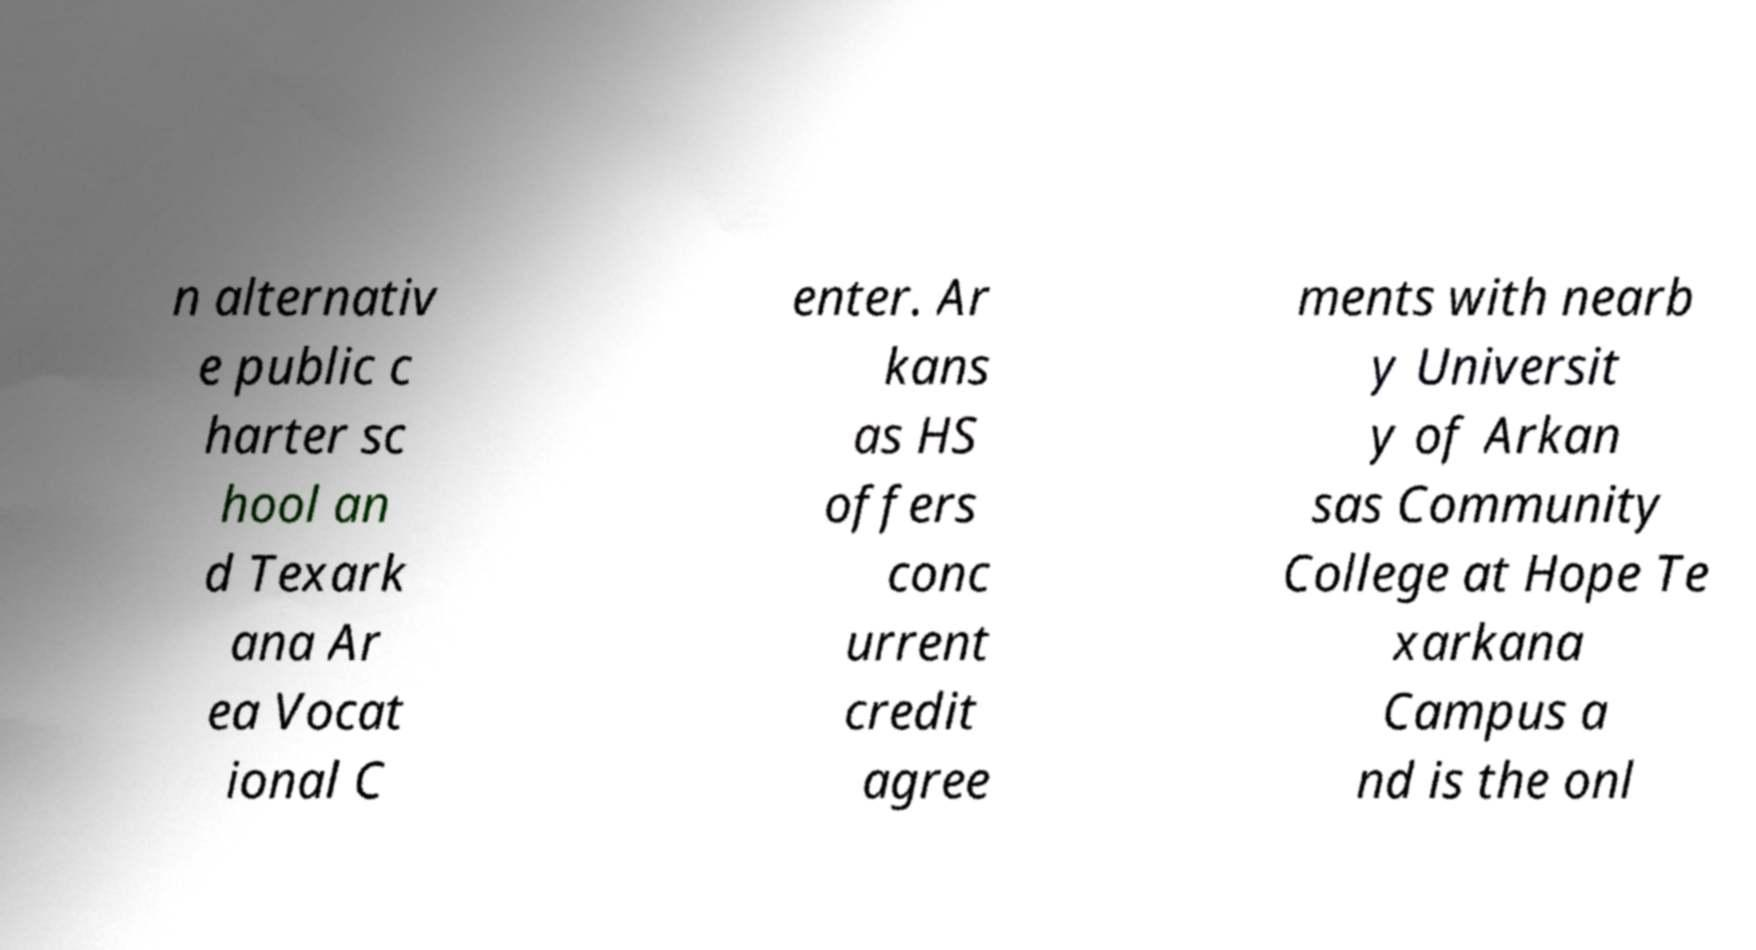Could you extract and type out the text from this image? n alternativ e public c harter sc hool an d Texark ana Ar ea Vocat ional C enter. Ar kans as HS offers conc urrent credit agree ments with nearb y Universit y of Arkan sas Community College at Hope Te xarkana Campus a nd is the onl 